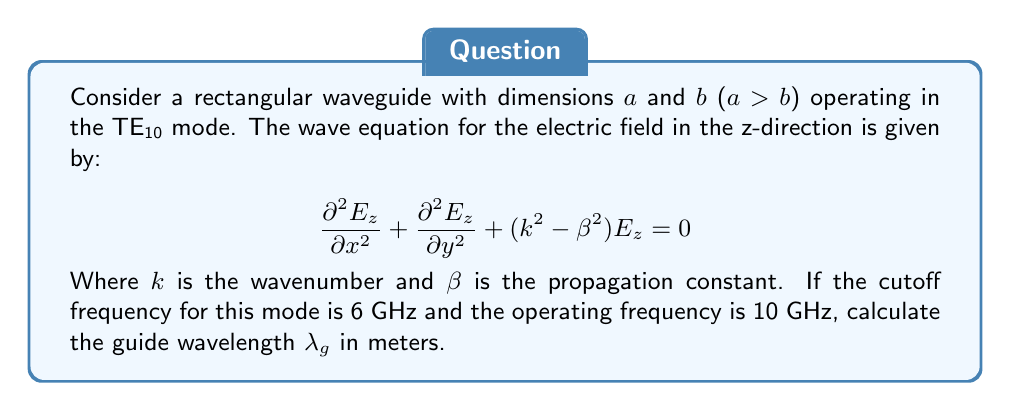Help me with this question. Let's approach this step-by-step:

1) For the TE10 mode in a rectangular waveguide, the cutoff frequency $f_c$ is given by:

   $$f_c = \frac{c}{2a}$$

   Where $c$ is the speed of light and $a$ is the width of the waveguide.

2) We're given that $f_c = 6$ GHz. Let's solve for $a$:

   $$a = \frac{c}{2f_c} = \frac{3 \times 10^8}{2 \times 6 \times 10^9} = 0.025 \text{ m}$$

3) The wavenumber $k$ is related to the operating frequency $f$:

   $$k = \frac{2\pi f}{c}$$

4) The propagation constant $\beta$ is given by:

   $$\beta = \sqrt{k^2 - (\frac{\pi}{a})^2}$$

5) Let's calculate $k$:

   $$k = \frac{2\pi \times 10 \times 10^9}{3 \times 10^8} = 209.44 \text{ m}^{-1}$$

6) Now we can calculate $\beta$:

   $$\beta = \sqrt{(209.44)^2 - (\frac{\pi}{0.025})^2} = 164.85 \text{ m}^{-1}$$

7) The guide wavelength $\lambda_g$ is related to $\beta$ by:

   $$\lambda_g = \frac{2\pi}{\beta}$$

8) Finally, we can calculate $\lambda_g$:

   $$\lambda_g = \frac{2\pi}{164.85} = 0.0381 \text{ m}$$
Answer: $\lambda_g = 0.0381 \text{ m}$ 